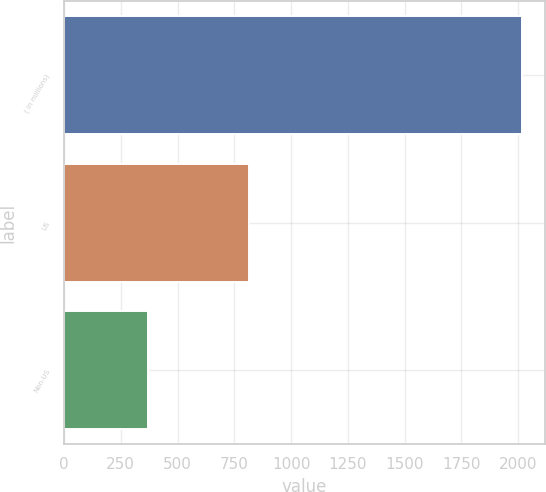Convert chart. <chart><loc_0><loc_0><loc_500><loc_500><bar_chart><fcel>( in millions)<fcel>US<fcel>Non-US<nl><fcel>2016<fcel>813<fcel>371<nl></chart> 